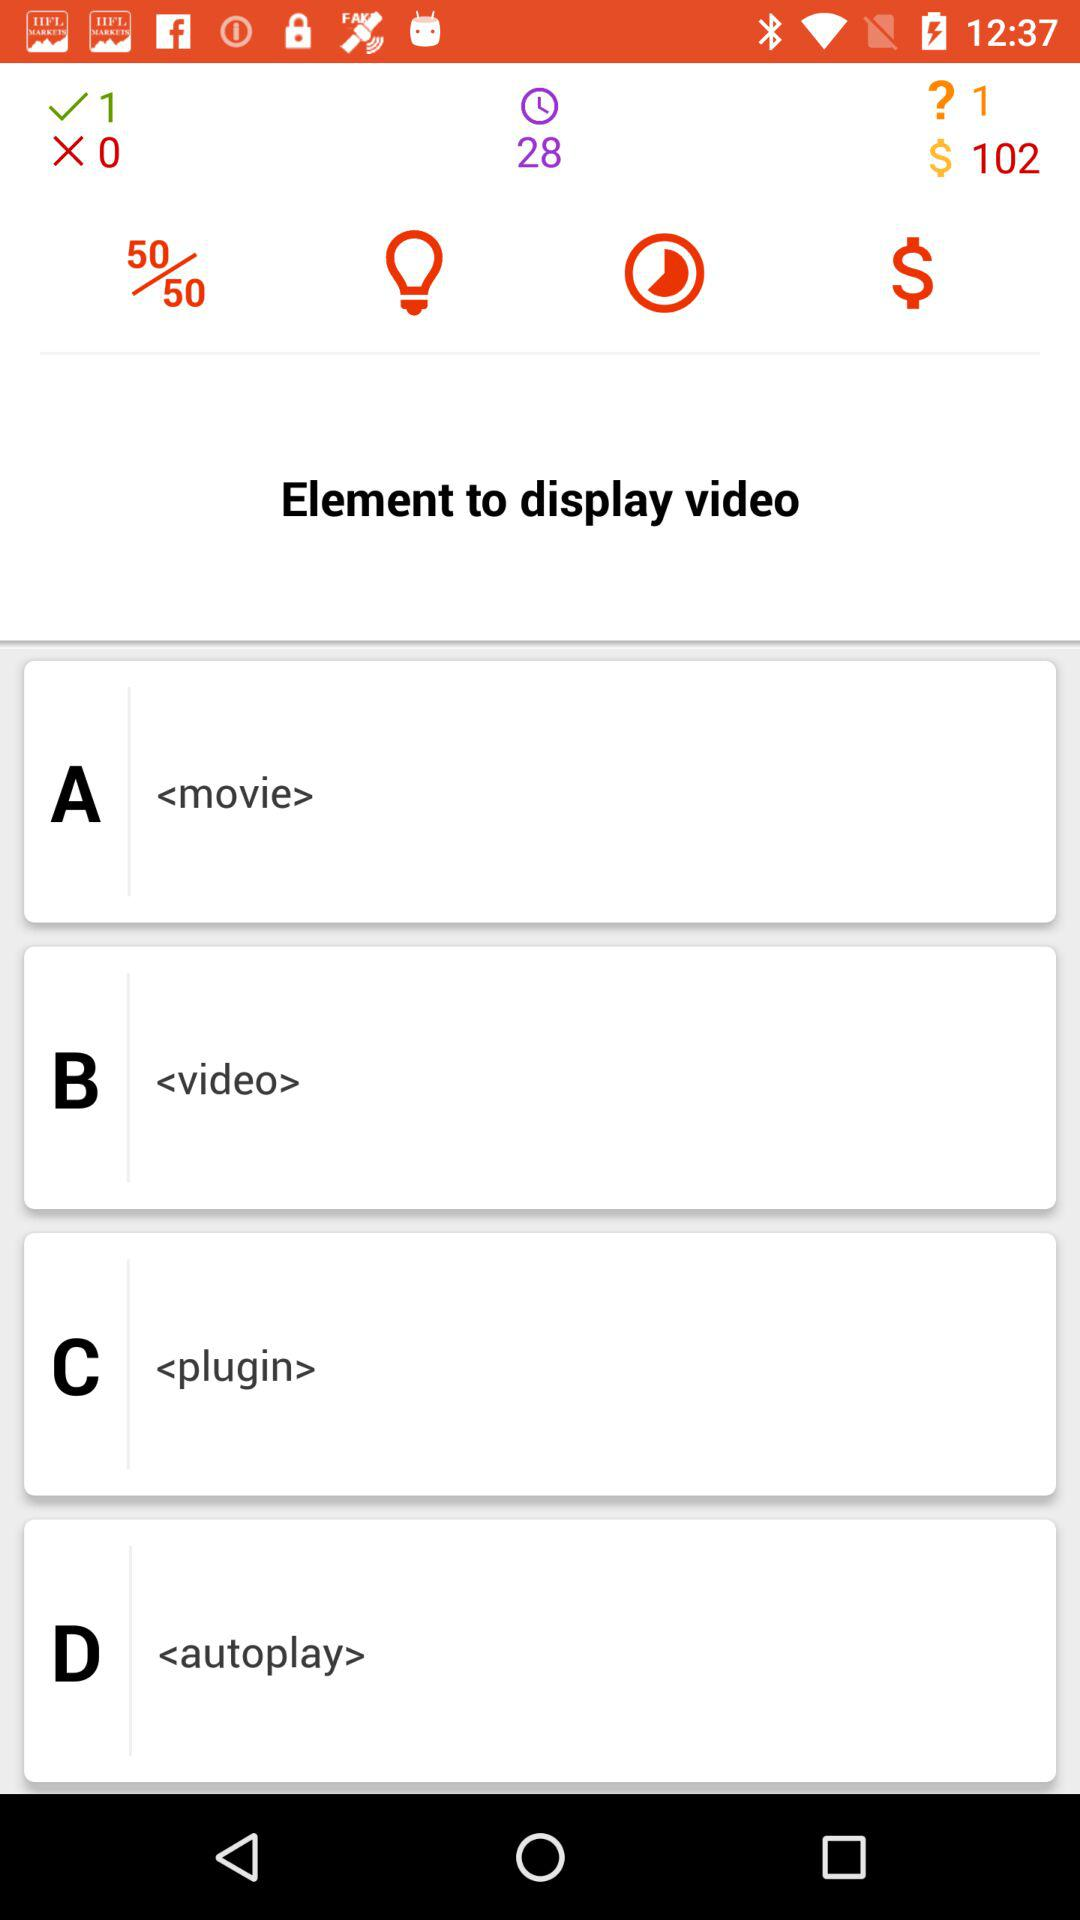How many lifelines are there?
When the provided information is insufficient, respond with <no answer>. <no answer> 